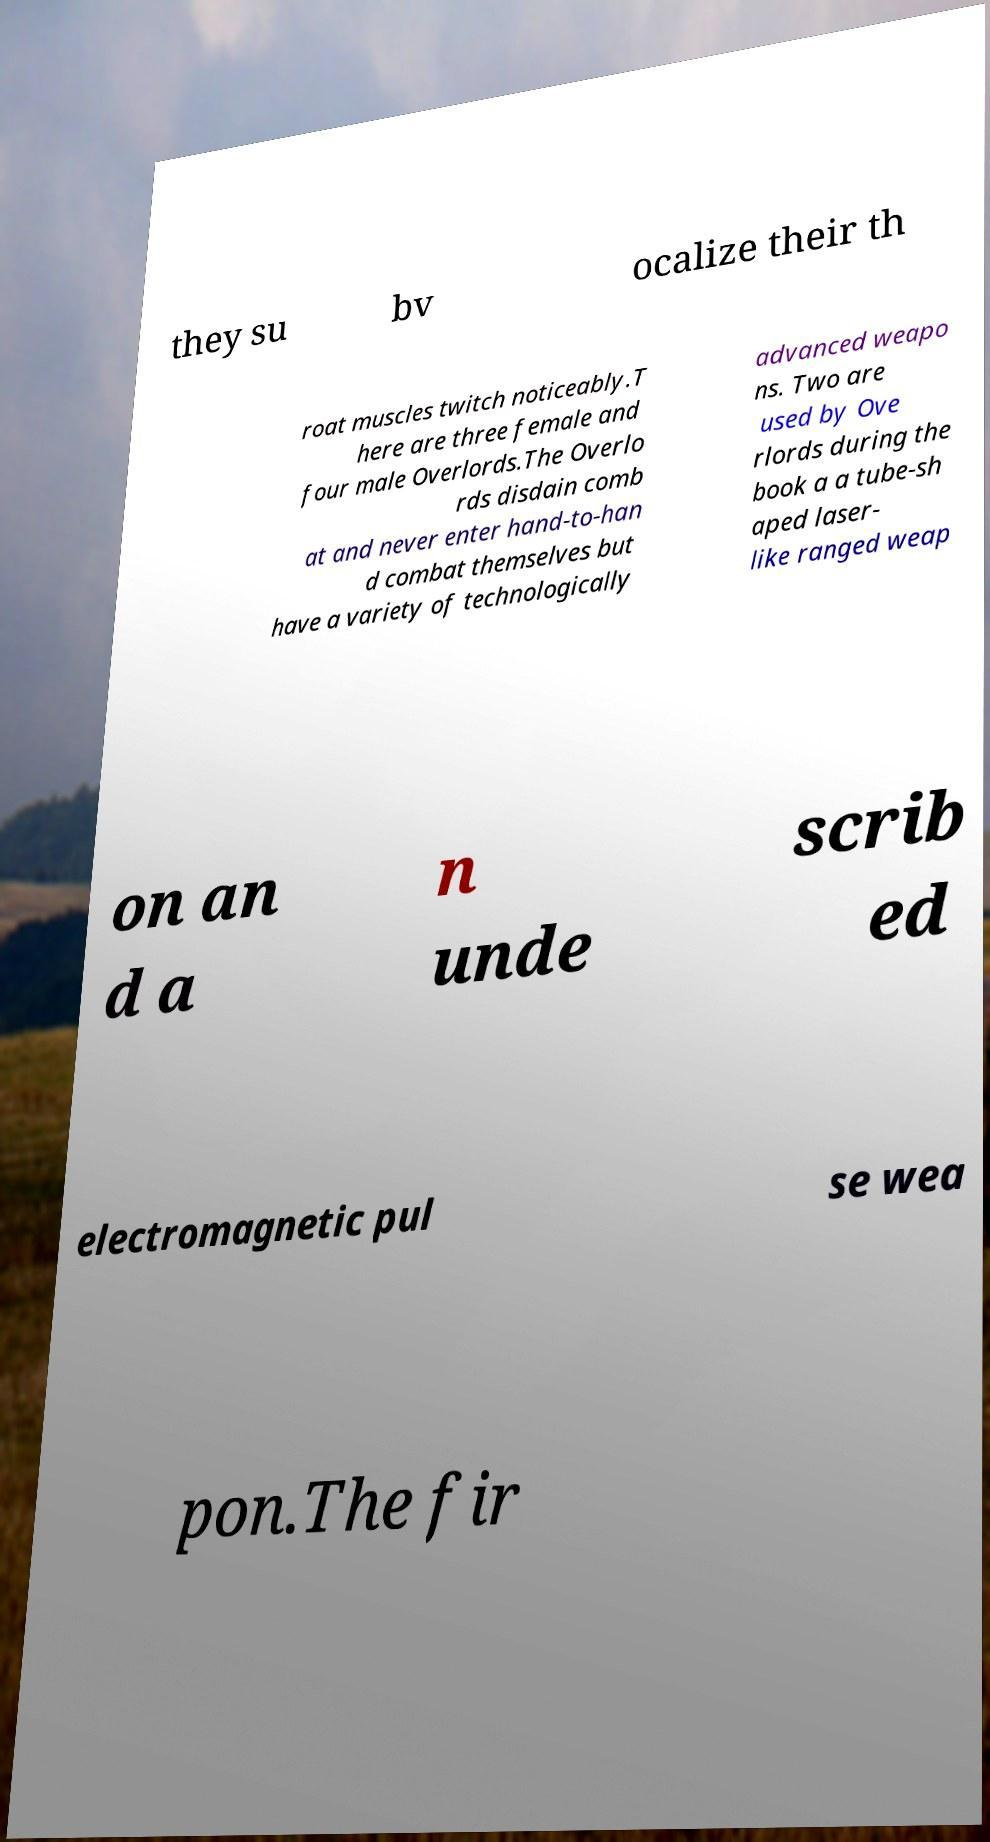Can you read and provide the text displayed in the image?This photo seems to have some interesting text. Can you extract and type it out for me? they su bv ocalize their th roat muscles twitch noticeably.T here are three female and four male Overlords.The Overlo rds disdain comb at and never enter hand-to-han d combat themselves but have a variety of technologically advanced weapo ns. Two are used by Ove rlords during the book a a tube-sh aped laser- like ranged weap on an d a n unde scrib ed electromagnetic pul se wea pon.The fir 